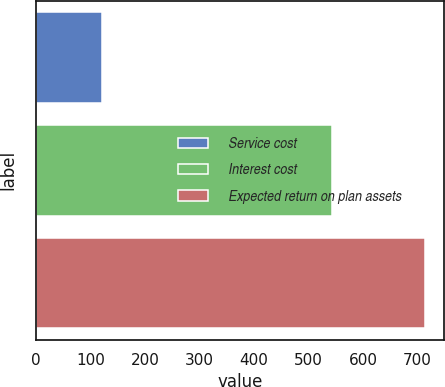Convert chart to OTSL. <chart><loc_0><loc_0><loc_500><loc_500><bar_chart><fcel>Service cost<fcel>Interest cost<fcel>Expected return on plan assets<nl><fcel>121<fcel>544<fcel>713<nl></chart> 